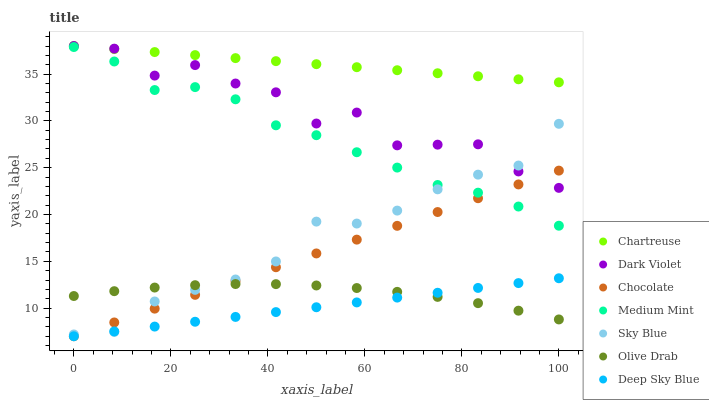Does Deep Sky Blue have the minimum area under the curve?
Answer yes or no. Yes. Does Chartreuse have the maximum area under the curve?
Answer yes or no. Yes. Does Dark Violet have the minimum area under the curve?
Answer yes or no. No. Does Dark Violet have the maximum area under the curve?
Answer yes or no. No. Is Chocolate the smoothest?
Answer yes or no. Yes. Is Dark Violet the roughest?
Answer yes or no. Yes. Is Dark Violet the smoothest?
Answer yes or no. No. Is Chocolate the roughest?
Answer yes or no. No. Does Chocolate have the lowest value?
Answer yes or no. Yes. Does Dark Violet have the lowest value?
Answer yes or no. No. Does Chartreuse have the highest value?
Answer yes or no. Yes. Does Chocolate have the highest value?
Answer yes or no. No. Is Medium Mint less than Dark Violet?
Answer yes or no. Yes. Is Chartreuse greater than Medium Mint?
Answer yes or no. Yes. Does Sky Blue intersect Chocolate?
Answer yes or no. Yes. Is Sky Blue less than Chocolate?
Answer yes or no. No. Is Sky Blue greater than Chocolate?
Answer yes or no. No. Does Medium Mint intersect Dark Violet?
Answer yes or no. No. 